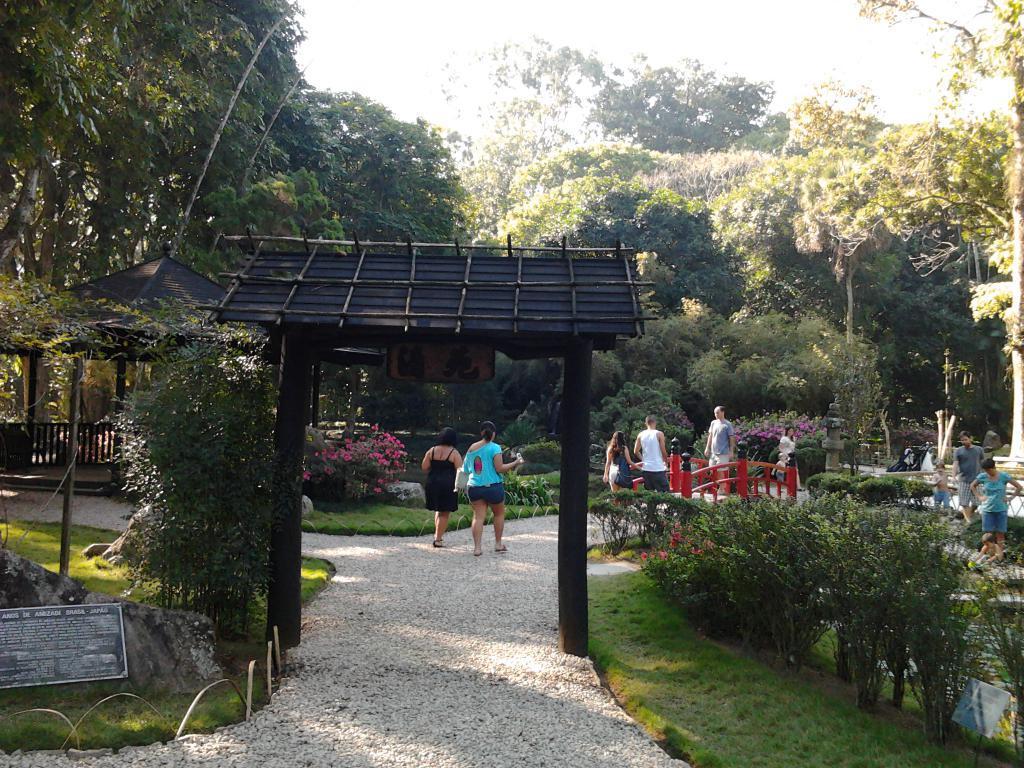Please provide a concise description of this image. In the image we can see there are many people walking and they are wearing clothes. Here we can see grass, plants, board and text on the board. Here we can see the tent, trees and the sky. 